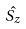<formula> <loc_0><loc_0><loc_500><loc_500>\hat { S _ { z } }</formula> 